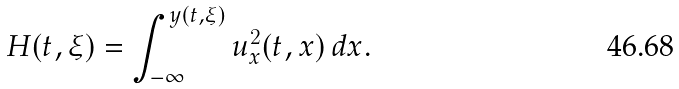<formula> <loc_0><loc_0><loc_500><loc_500>H ( t , \xi ) = \int _ { - \infty } ^ { y ( t , \xi ) } u _ { x } ^ { 2 } ( t , x ) \, d x .</formula> 